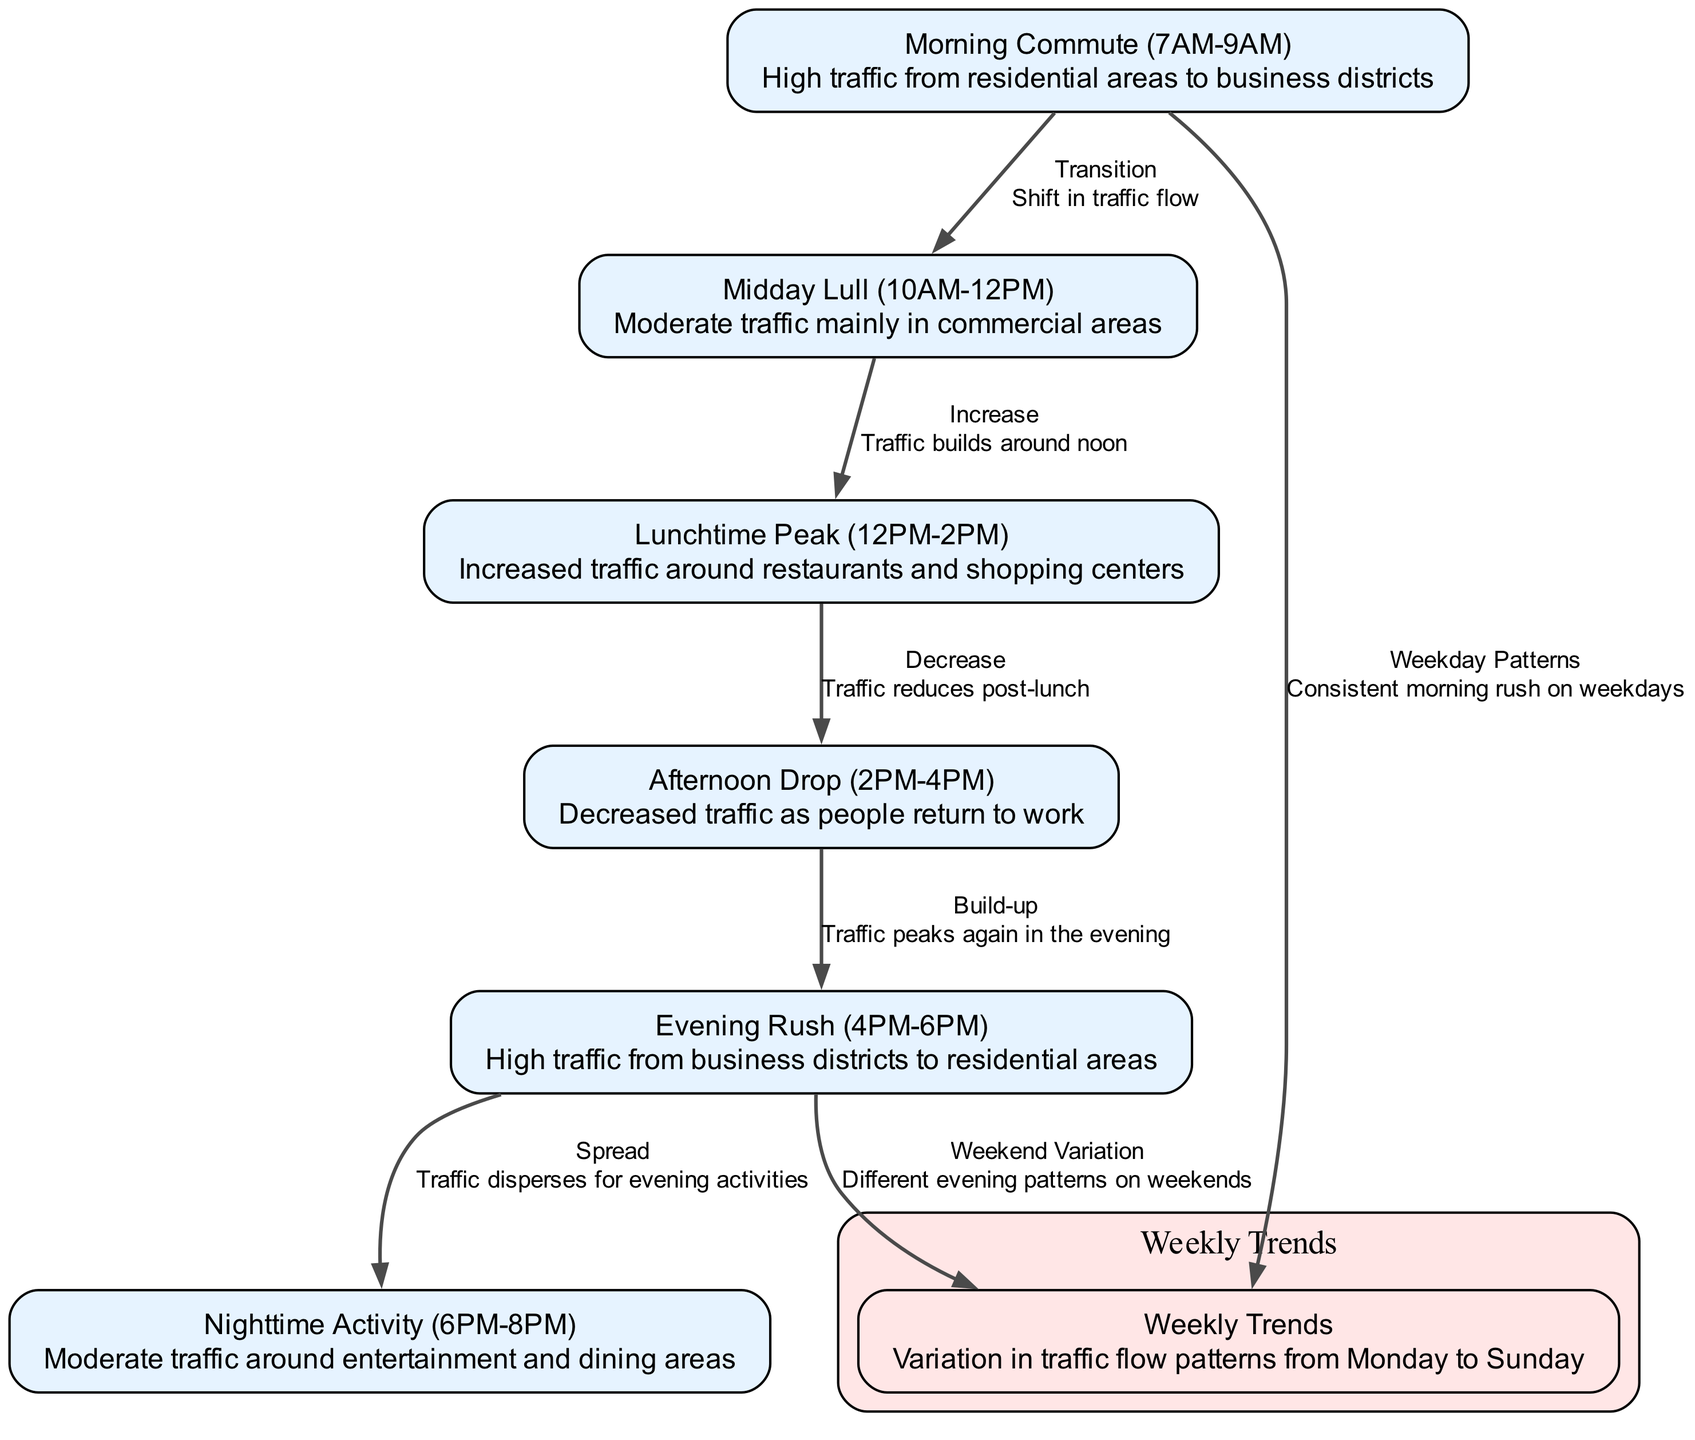What is the label of the node representing lunchtime? The node corresponding to lunchtime is labeled "Lunchtime Peak (12PM-2PM)". This is directly derived from the data provided in the nodes section where the lunch-related traffic is identified clearly.
Answer: Lunchtime Peak (12PM-2PM) How many peak traffic times are there in the diagram? The diagram has three distinct peak traffic times marked as "Morning Commute", "Lunchtime Peak", and "Evening Rush". Counting these peak periods from the nodes, we can ascertain that there are a total of three identified peak times.
Answer: 3 What is the relationship between "Midday Lull" and "Lunchtime Peak"? The relationship is labeled as "Increase". According to the edges, this means traffic builds from the midday lull into the lunchtime peak, indicating a transition from moderate to increased traffic flow.
Answer: Increase Which node indicates high traffic in the evening? The "Evening Rush (4PM-6PM)" node denotes high traffic levels during the evening. This is specified in the node description, clearly indicating this time frame is associated with high traffic flow.
Answer: Evening Rush (4PM-6PM) What describes traffic conditions between "Afternoon Drop" and "Evening Rush"? The condition is described as "Build-up". This indicates that there is a transition in traffic flow where, after a decrease in the afternoon, traffic begins to increase again in anticipation of the evening rush as noted in the edges section.
Answer: Build-up Which node showcases weekly variations in traffic? The "Weekly Trends" node is specifically established to indicate variations in traffic flow patterns throughout the week. This node summarizes the influence of weekday and weekend on the traffic flow.
Answer: Weekly Trends What happens to traffic after the "Evening Rush"? Traffic disperses into nighttime activities, as indicated by the "Spread" description from the edge leading to the "Nighttime Activity" node. This demonstrates the transition to moderate traffic as people engage in evening activities.
Answer: Spread What is the timeframe for the "Nighttime Activity" node? The "Nighttime Activity" node is defined for the period from 6PM to 8PM, as noted in the node label which specifies its occurrence during evening hours.
Answer: 6PM-8PM What does the "Weekday Patterns" edge connect to? The "Weekday Patterns" edge connects the "Morning Commute" node to the "Weekly Trends" node, indicating consistent morning traffic during weekdays. This relationship emphasizes a regular traffic flow on weekdays compared to weekends.
Answer: Weekly Trends 